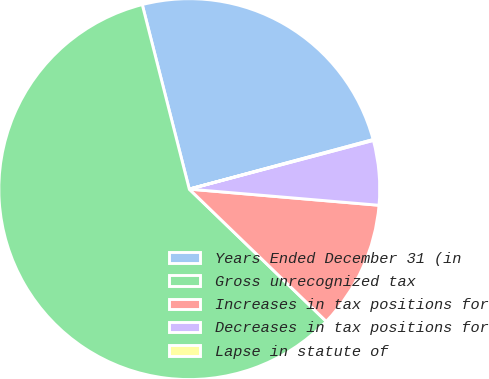Convert chart to OTSL. <chart><loc_0><loc_0><loc_500><loc_500><pie_chart><fcel>Years Ended December 31 (in<fcel>Gross unrecognized tax<fcel>Increases in tax positions for<fcel>Decreases in tax positions for<fcel>Lapse in statute of<nl><fcel>24.78%<fcel>58.8%<fcel>10.87%<fcel>5.47%<fcel>0.07%<nl></chart> 